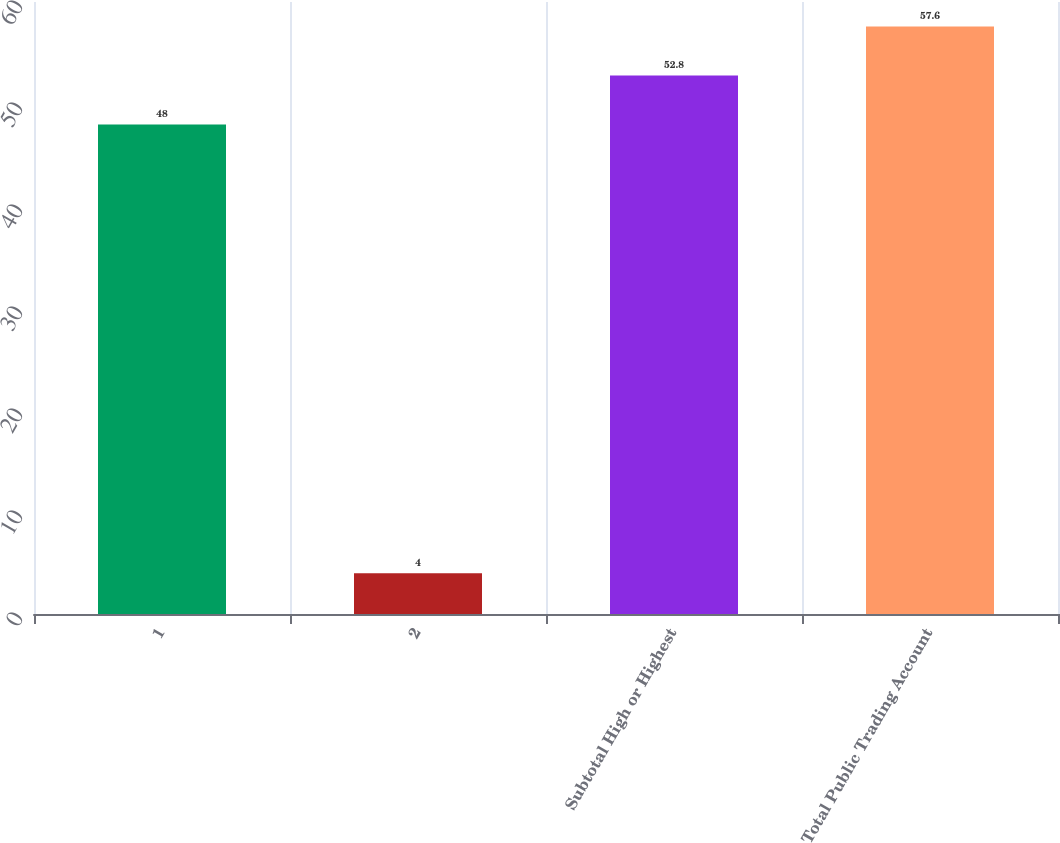Convert chart. <chart><loc_0><loc_0><loc_500><loc_500><bar_chart><fcel>1<fcel>2<fcel>Subtotal High or Highest<fcel>Total Public Trading Account<nl><fcel>48<fcel>4<fcel>52.8<fcel>57.6<nl></chart> 